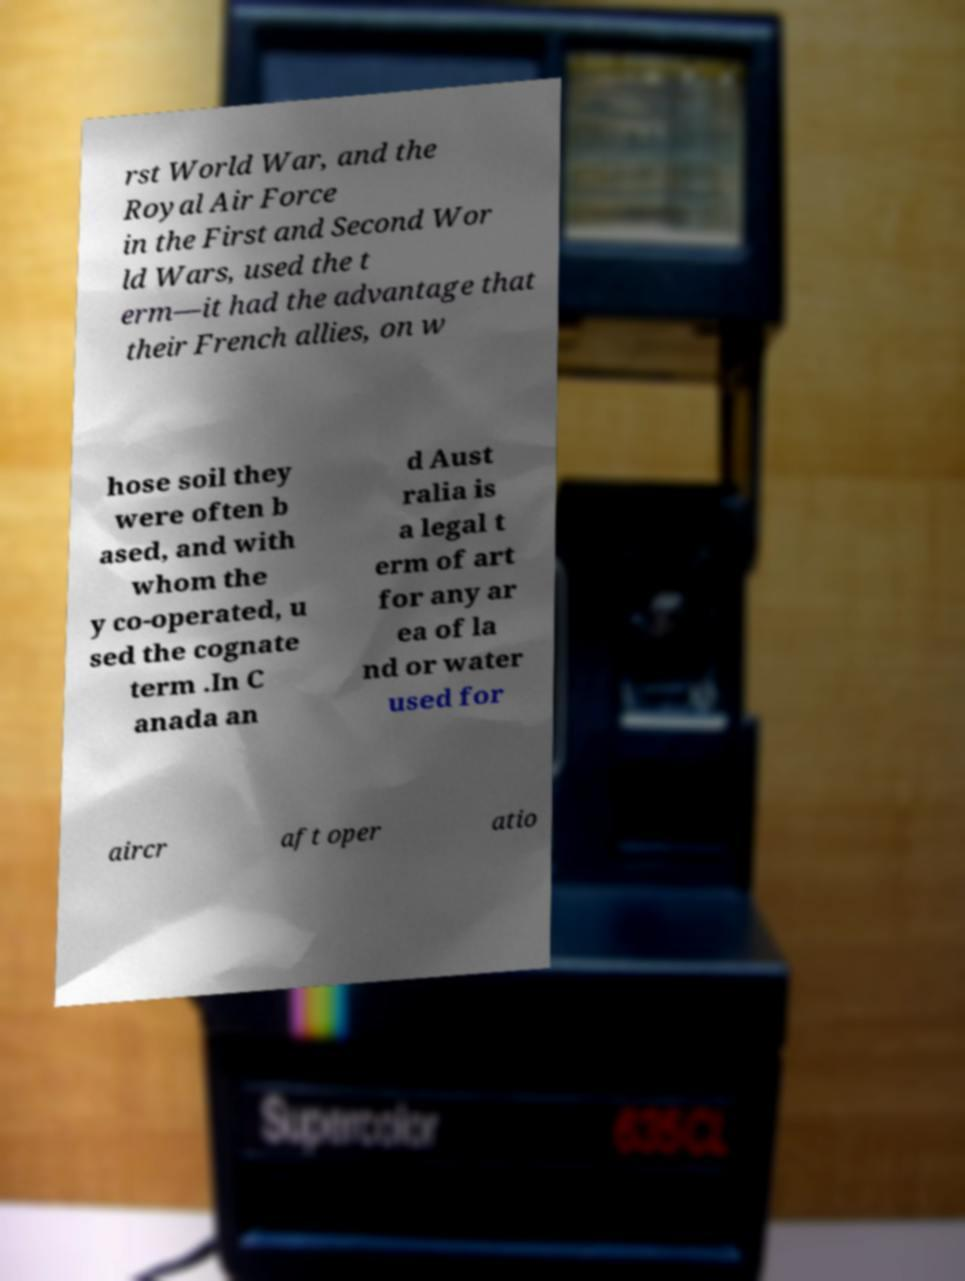Please identify and transcribe the text found in this image. rst World War, and the Royal Air Force in the First and Second Wor ld Wars, used the t erm—it had the advantage that their French allies, on w hose soil they were often b ased, and with whom the y co-operated, u sed the cognate term .In C anada an d Aust ralia is a legal t erm of art for any ar ea of la nd or water used for aircr aft oper atio 